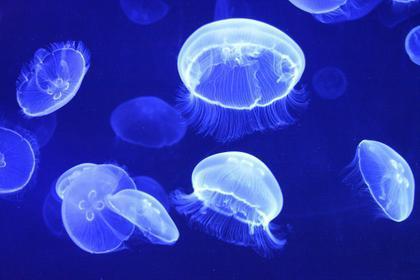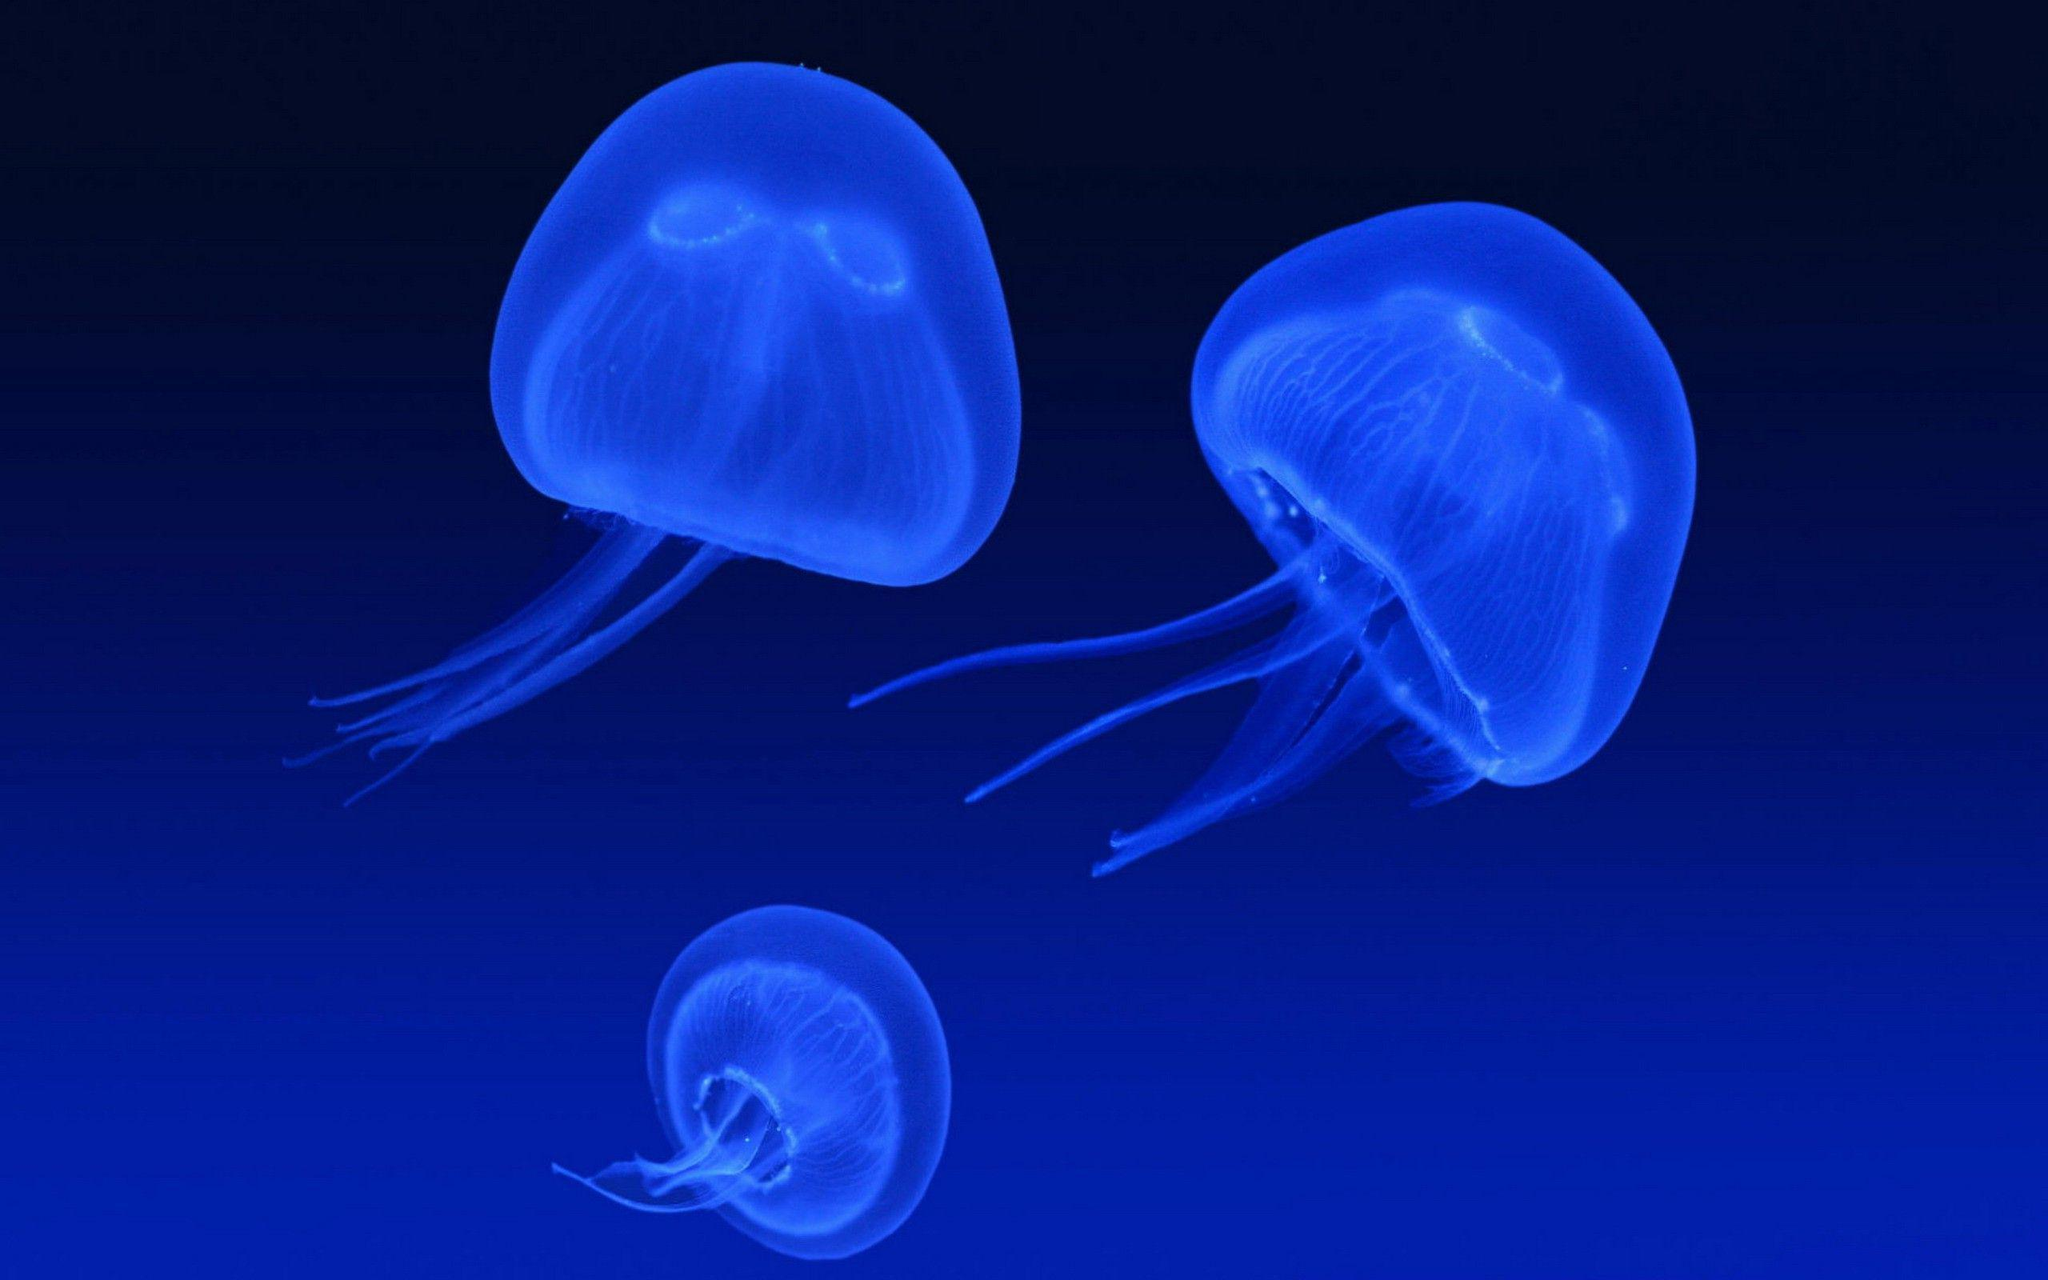The first image is the image on the left, the second image is the image on the right. Given the left and right images, does the statement "In the image on the right, exactly 2  jellyfish are floating  above 1 smaller jellyfish." hold true? Answer yes or no. Yes. 